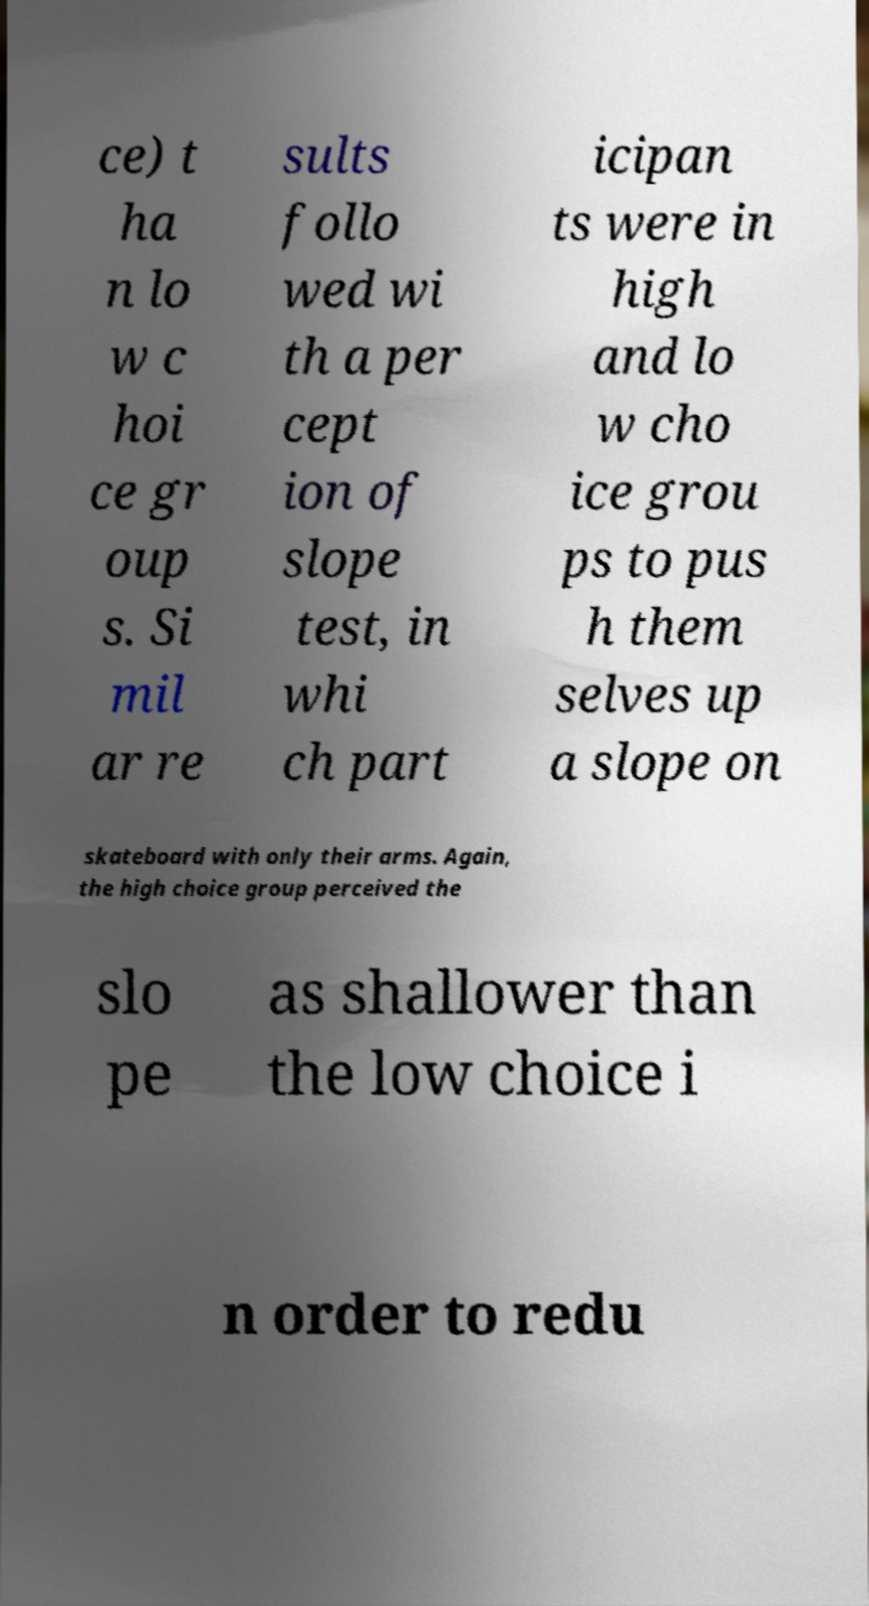Please identify and transcribe the text found in this image. ce) t ha n lo w c hoi ce gr oup s. Si mil ar re sults follo wed wi th a per cept ion of slope test, in whi ch part icipan ts were in high and lo w cho ice grou ps to pus h them selves up a slope on skateboard with only their arms. Again, the high choice group perceived the slo pe as shallower than the low choice i n order to redu 